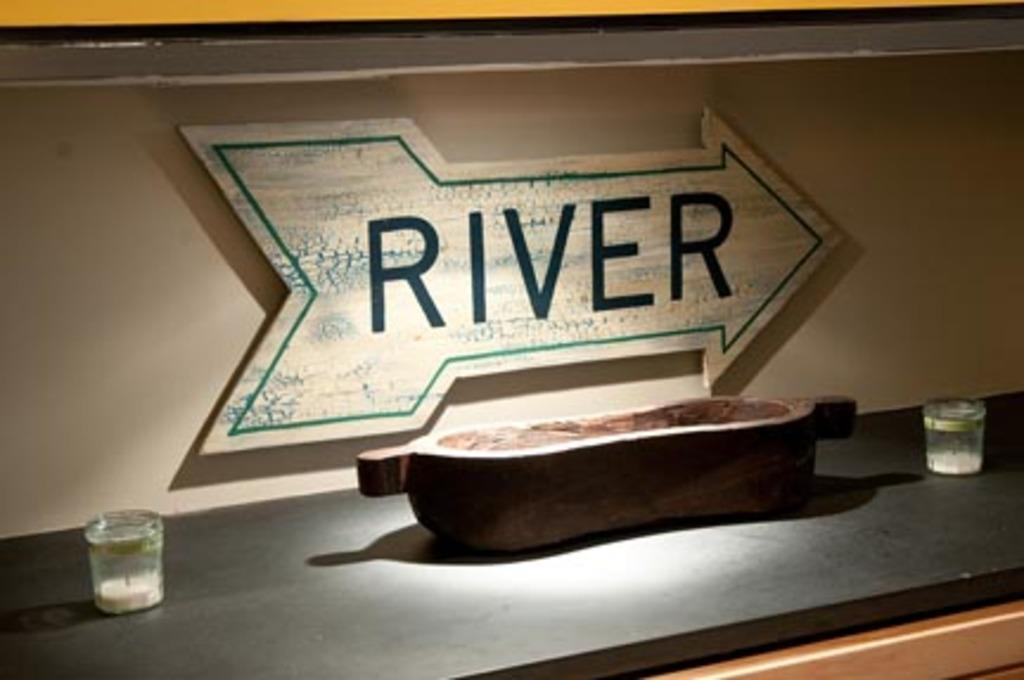<image>
Give a short and clear explanation of the subsequent image. an arrow shaped sign reading RIVER on display 